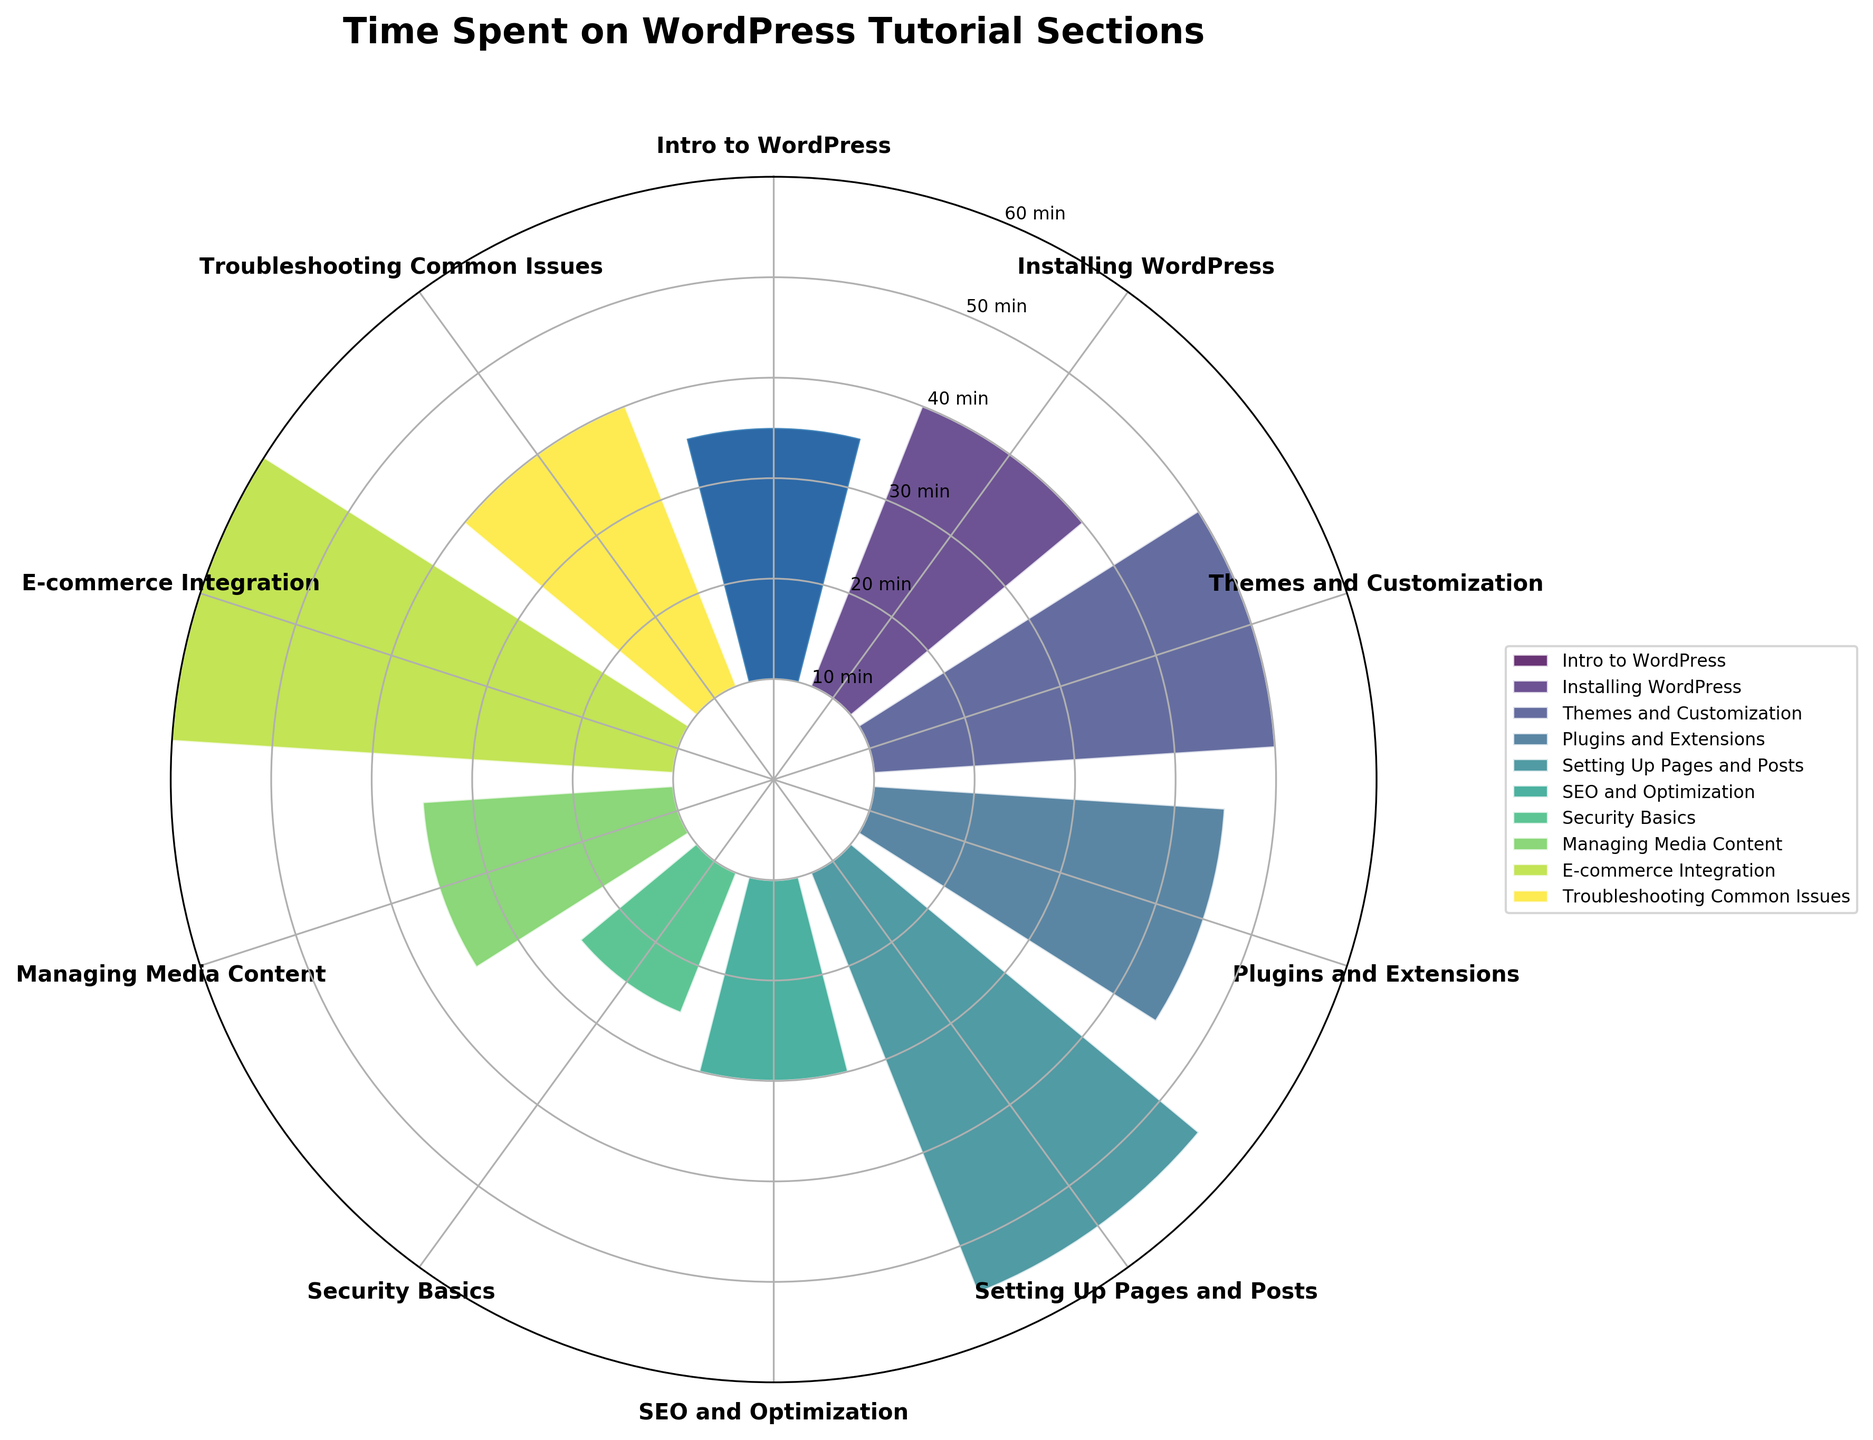How many sections are represented in the chart? There are 10 sections represented, as can be seen from the different bars and labels around the polar area chart.
Answer: 10 Which WordPress tutorial section has the highest time spent on average? The section with the highest bar, which extends the furthest from the center, represents the highest time spent. The label for this section is "E-commerce Integration."
Answer: E-commerce Integration What's the combined time spent on the "Installing WordPress" and "Troubleshooting Common Issues" sections? Refer to the bars for "Installing WordPress" and "Troubleshooting Common Issues." The time spent is 30 and 30 minutes respectively. Add these values together: 30 + 30.
Answer: 60 minutes Is the average time spent on "SEO and Optimization" greater than "Security Basics"? Compare the bars for "SEO and Optimization" and "Security Basics." The bar for "SEO and Optimization" is 20 minutes, while the bar for "Security Basics" is 15 minutes. 20 is greater than 15.
Answer: Yes What is the range of time spent across all sections? The range is the difference between the highest and lowest values. The highest value (for "E-commerce Integration") is 50 minutes and the lowest value (for "Security Basics") is 15 minutes. 50 - 15 = 35.
Answer: 35 minutes Which two sections have the same average time spent? Find bars of the same length. "Installing WordPress" and "Troubleshooting Common Issues" both have bars with 30 minutes each.
Answer: Installing WordPress and Troubleshooting Common Issues What is the median time spent across all sections? First, list the time values in ascending order: 15, 20, 25, 25, 30, 30, 35, 40, 45, 50. The median value is the middle number in this ordered list. Since there are 10 values, the median is the average of the 5th and 6th values: (30 + 30) / 2.
Answer: 30 minutes How does the time spent on "Themes and Customization" compare to the time spent on "Plugins and Extensions"? Compare the heights of the bars for "Themes and Customization" (40 minutes) and "Plugins and Extensions" (35 minutes). 40 is greater than 35.
Answer: Themes and Customization is 5 minutes longer Which section has the shortest time spent, and what is its value? The shortest bar indicates the section with the least time spent. The label for this section is "Security Basics" with 15 minutes.
Answer: Security Basics with 15 minutes Are there any sections where the time spent is below 20 minutes? Look for bars that are shorter than the 20-minute mark. Only the "Security Basics" section meets this criterion.
Answer: Yes, Security Basics 